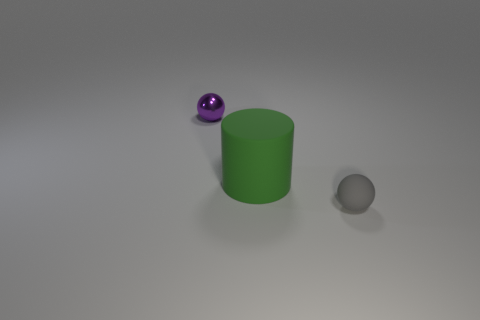Add 1 large rubber cylinders. How many objects exist? 4 Subtract all cylinders. How many objects are left? 2 Subtract 0 purple cylinders. How many objects are left? 3 Subtract all yellow balls. Subtract all metal balls. How many objects are left? 2 Add 2 big green matte cylinders. How many big green matte cylinders are left? 3 Add 3 big yellow matte objects. How many big yellow matte objects exist? 3 